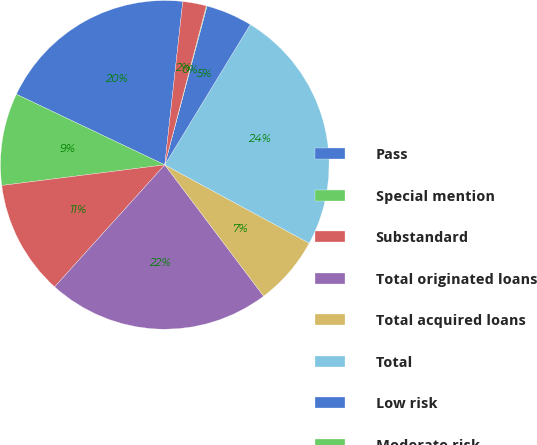Convert chart to OTSL. <chart><loc_0><loc_0><loc_500><loc_500><pie_chart><fcel>Pass<fcel>Special mention<fcel>Substandard<fcel>Total originated loans<fcel>Total acquired loans<fcel>Total<fcel>Low risk<fcel>Moderate risk<fcel>High risk<nl><fcel>19.68%<fcel>9.07%<fcel>11.31%<fcel>21.96%<fcel>6.82%<fcel>24.2%<fcel>4.57%<fcel>0.07%<fcel>2.32%<nl></chart> 